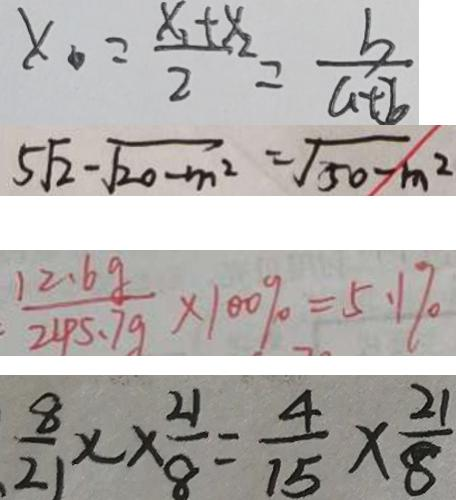Convert formula to latex. <formula><loc_0><loc_0><loc_500><loc_500>x = \frac { x _ { 1 } + x _ { 2 } } { 2 } = \frac { b } { a + b } 
 5 \sqrt { 2 } - \sqrt { 2 0 - m ^ { 2 } } = \sqrt { 5 0 - m ^ { 2 } } 
 \frac { 1 2 . 6 g } { 2 4 5 . 7 g } \times 1 0 0 \% = 5 . 1 \% 
 \frac { 8 } { 2 } \times \frac { 2 1 } { 8 } = \frac { 4 } { 1 5 } \times \frac { 2 1 } { 8 }</formula> 